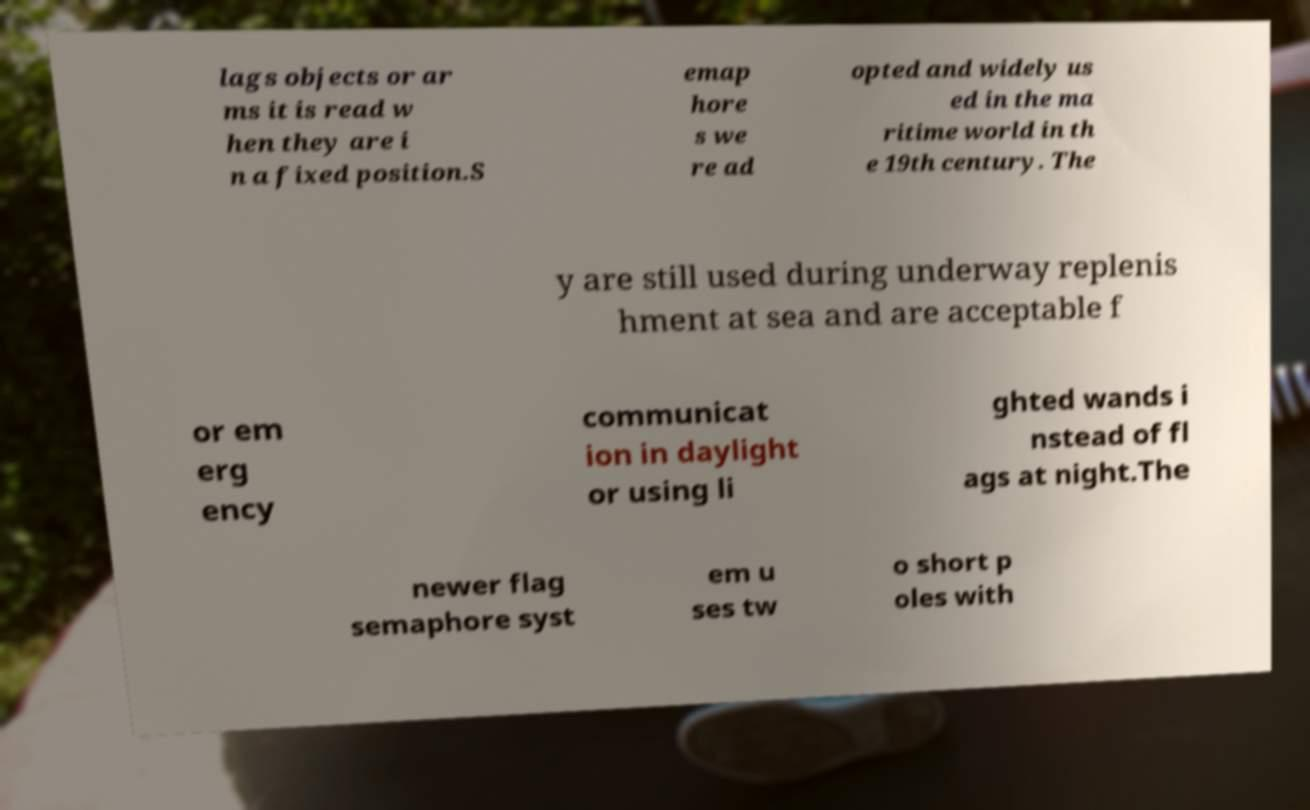What messages or text are displayed in this image? I need them in a readable, typed format. lags objects or ar ms it is read w hen they are i n a fixed position.S emap hore s we re ad opted and widely us ed in the ma ritime world in th e 19th century. The y are still used during underway replenis hment at sea and are acceptable f or em erg ency communicat ion in daylight or using li ghted wands i nstead of fl ags at night.The newer flag semaphore syst em u ses tw o short p oles with 